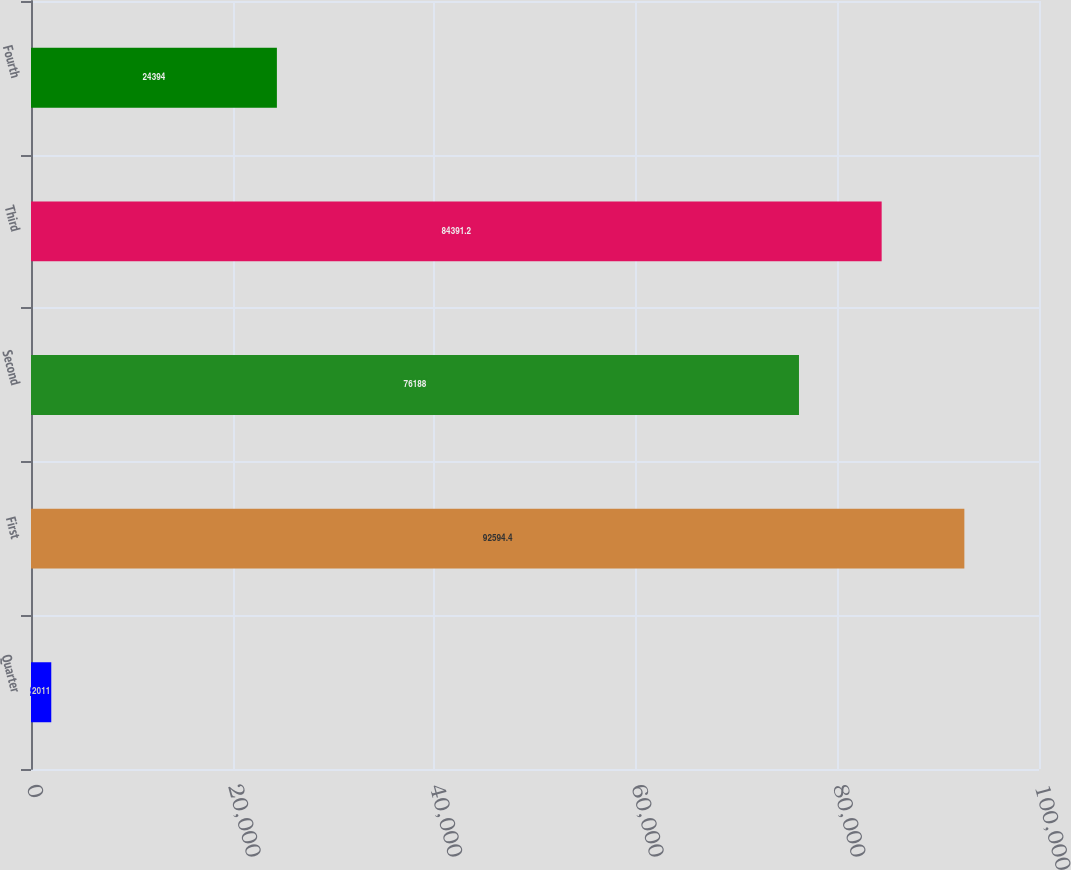Convert chart. <chart><loc_0><loc_0><loc_500><loc_500><bar_chart><fcel>Quarter<fcel>First<fcel>Second<fcel>Third<fcel>Fourth<nl><fcel>2011<fcel>92594.4<fcel>76188<fcel>84391.2<fcel>24394<nl></chart> 